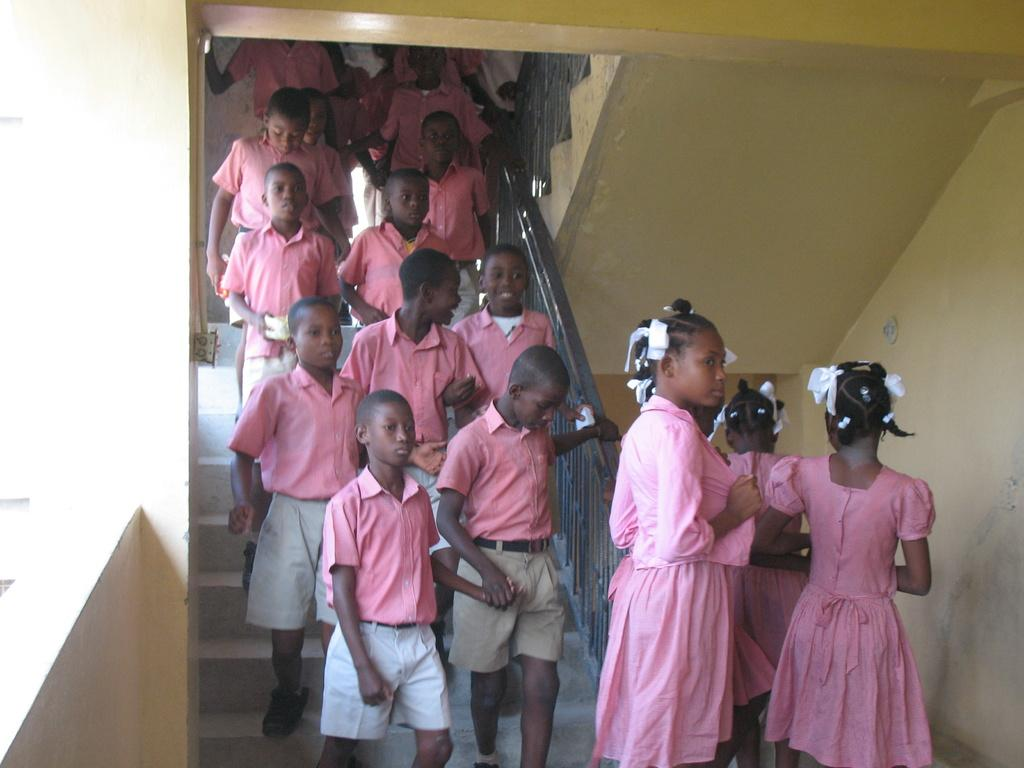Who is present in the image? There are children in the image. What are the children doing in the image? The children are walking on steps. Where is the horse in the image? There is no horse present in the image. What type of kitten can be seen playing with the children in the image? There is no kitten present in the image; only the children are visible. 